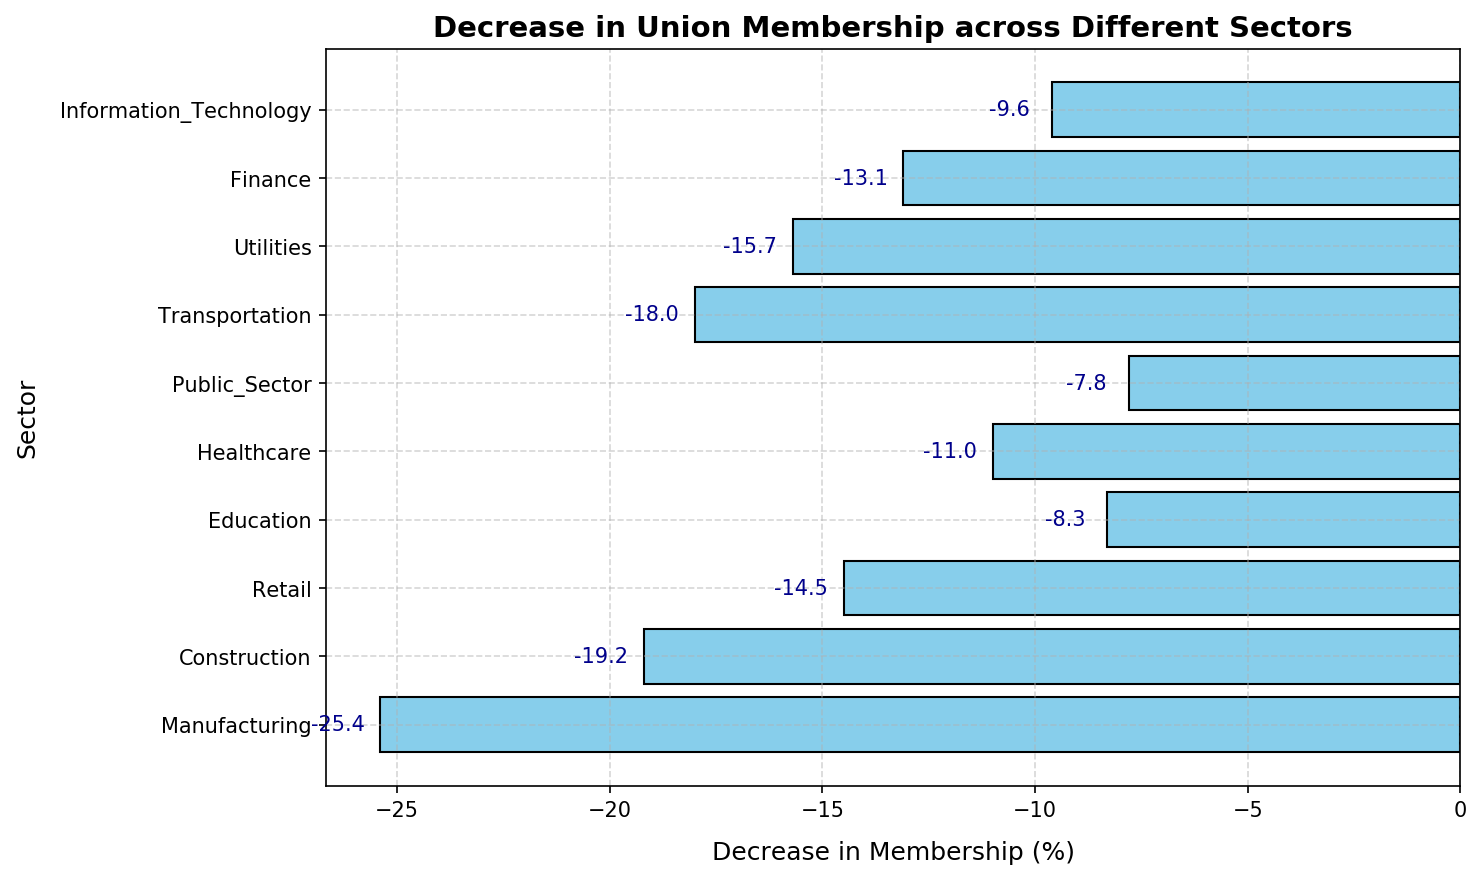Which sector saw the largest decrease in union membership? By visually scanning the bars, the Manufacturing sector has the longest bar extending to the left, indicating the highest decrease.
Answer: Manufacturing Which sector saw the smallest decrease in union membership? By observing the shortest bar, the Public Sector has the smallest extension to the left, indicating the smallest decrease.
Answer: Public Sector What is the total decrease in union membership for Healthcare, Education, and Retail sectors? Adding the values for Healthcare (-11.0), Education (-8.3), and Retail (-14.5) results in -11.0 - 8.3 - 14.5 = -33.8.
Answer: -33.8 Is the decrease in union membership in the Construction sector greater than that in the Retail sector? By comparing the values, Construction (-19.2) has a greater decrease than Retail (-14.5).
Answer: Yes Are there more sectors with a decrease greater than or equal to 10% or with a decrease less than 10%? Sectors with a decrease ≥ 10%: Manufacturing, Construction, Retail, Healthcare, Transportation, Utilities, Finance; sectors with a decrease < 10%: Education, Public Sector, Information Technology. There are 7 sectors with a decrease ≥ 10% and 3 sectors with a decrease < 10%.
Answer: More sectors have a decrease ≥ 10% What is the average decrease in union membership across all sectors? Sum all decreases: -25.4 - 19.2 - 14.5 - 8.3 - 11.0 - 7.8 - 18.0 - 15.7 - 13.1 - 9.6 = -142.6. Divide by the number of sectors (10): -142.6 / 10 = -14.26.
Answer: -14.26 Which sector saw a decrease closer to -15%: Finance or Transportation? By comparing the absolute differences: Finance (-13.1 is 1.9 away from -15) and Transportation (-18.0 is 3 away). Finance has a decrease closer to -15.
Answer: Finance Are there any sectors with a decrease exactly at -10%? By scanning the values, none of the sectors have a decrease of exactly -10%.
Answer: No Which two sectors combined had a decrease in union membership of exactly -30%? By examining possible pairs: Construction (-19.2) and Public Sector (-7.8) together equal -27%, but Construction (-19.2) and Information Technology (-9.6) together equal -28.8%. No combination exactly matches -30%.
Answer: None 